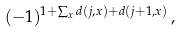Convert formula to latex. <formula><loc_0><loc_0><loc_500><loc_500>( - 1 ) ^ { 1 + \sum _ { x } d ( j , x ) + d ( j + 1 , x ) } \, ,</formula> 